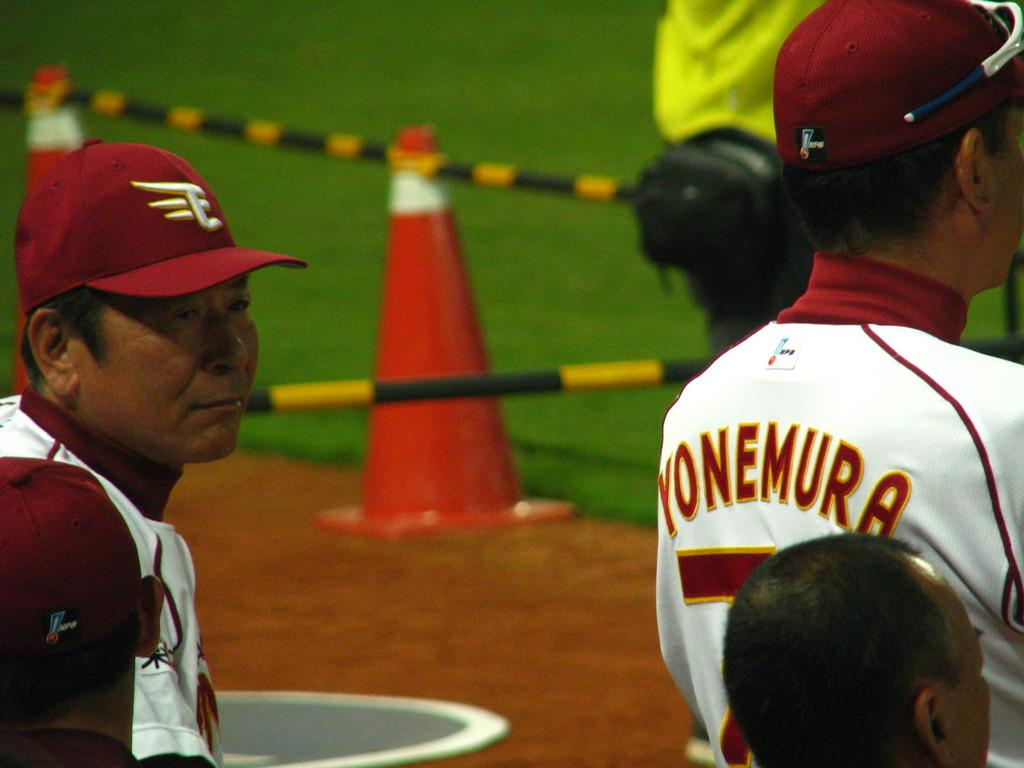<image>
Create a compact narrative representing the image presented. A man wearing a red hat stands behind a man wearing a Yonemura jersey. 